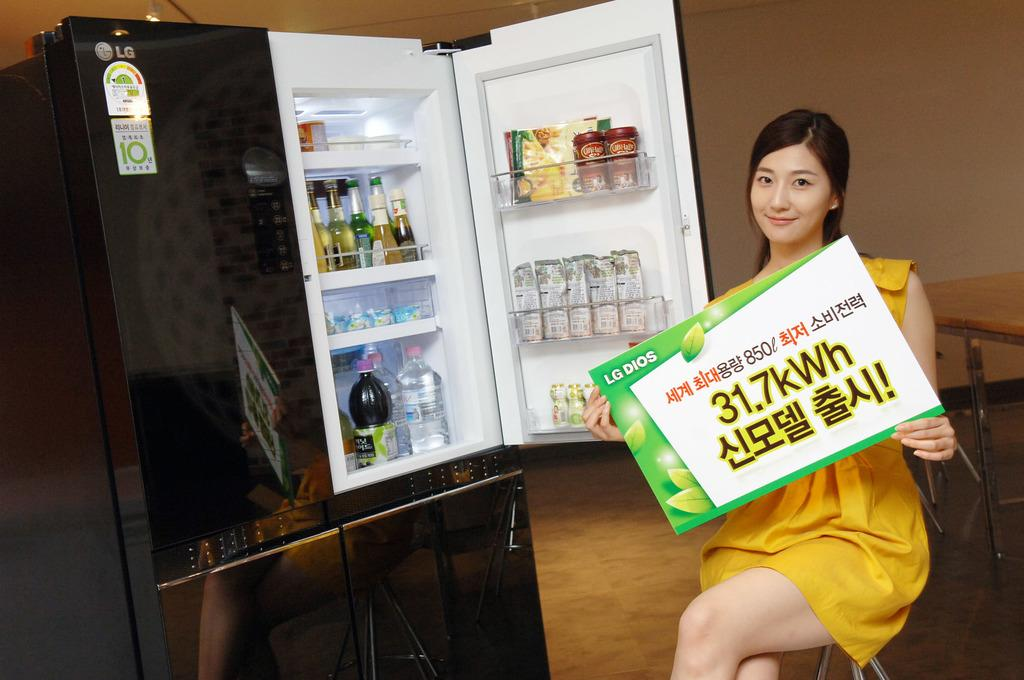<image>
Share a concise interpretation of the image provided. A woman in a yellow dress holds a sign that says 31.7kWh on it. 